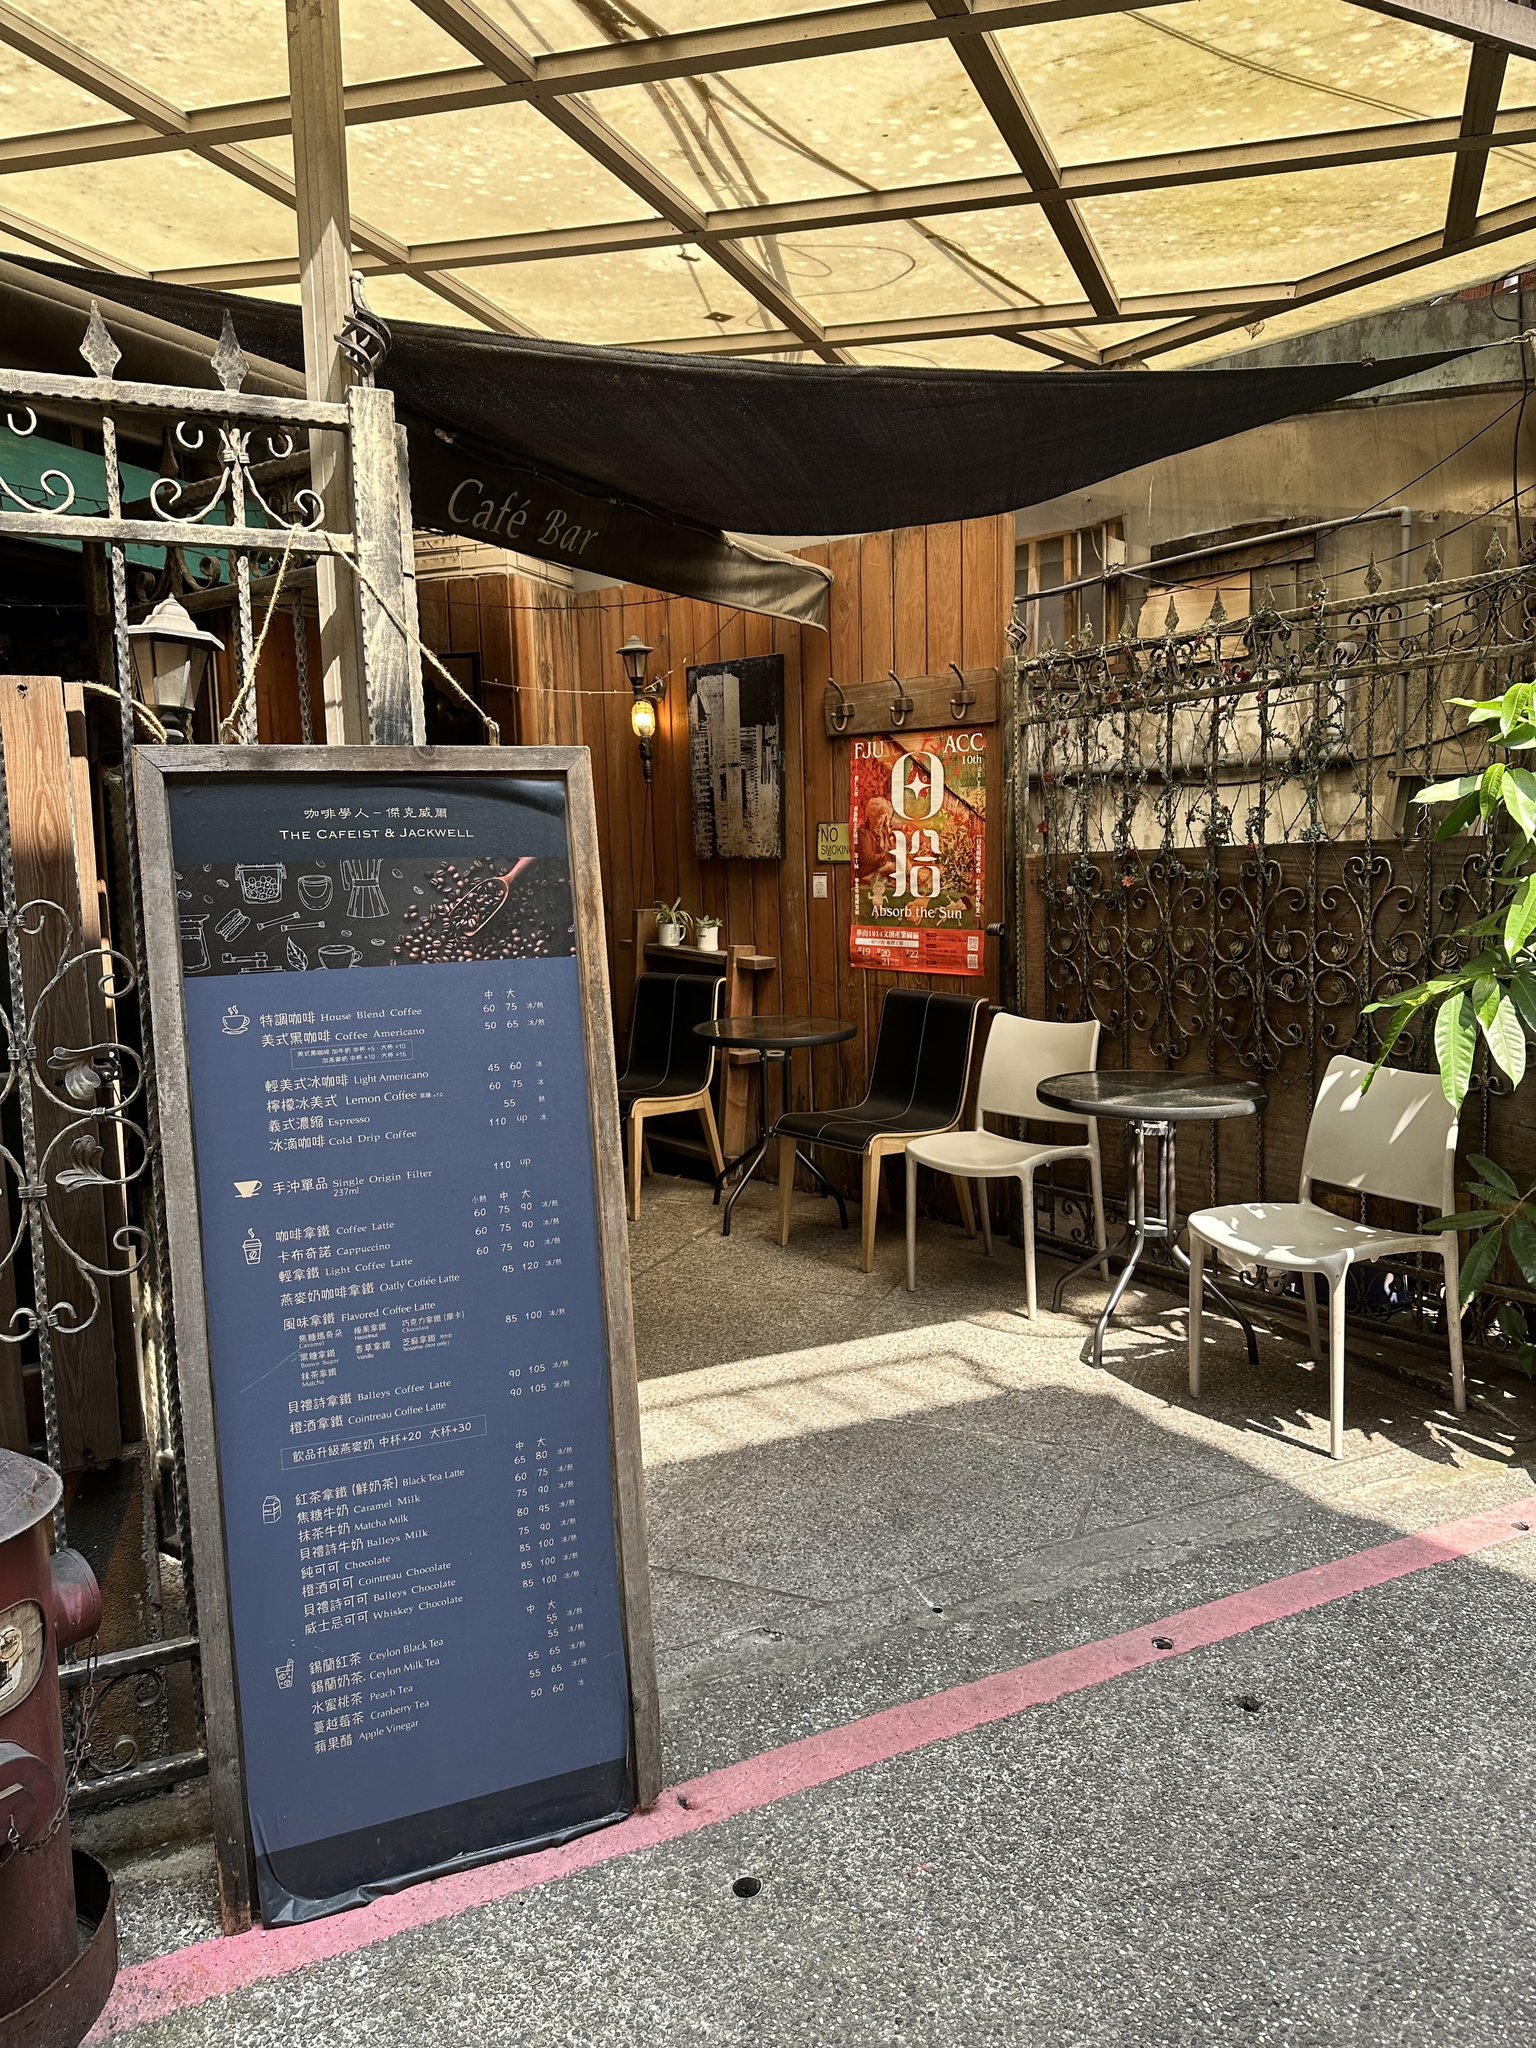How much does a medium hot latte cost? The text on the board is a bit small and difficult to read clearly. However, I can try to enhance the image and provide an answer if the text becomes legible. Let's give it a try. 

After enhancing the image, I can see that a medium hot latte is listed at a price of 110. The currency is not visible, but you can likely infer it based on the location of the cafe. 